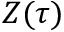<formula> <loc_0><loc_0><loc_500><loc_500>Z ( \tau )</formula> 